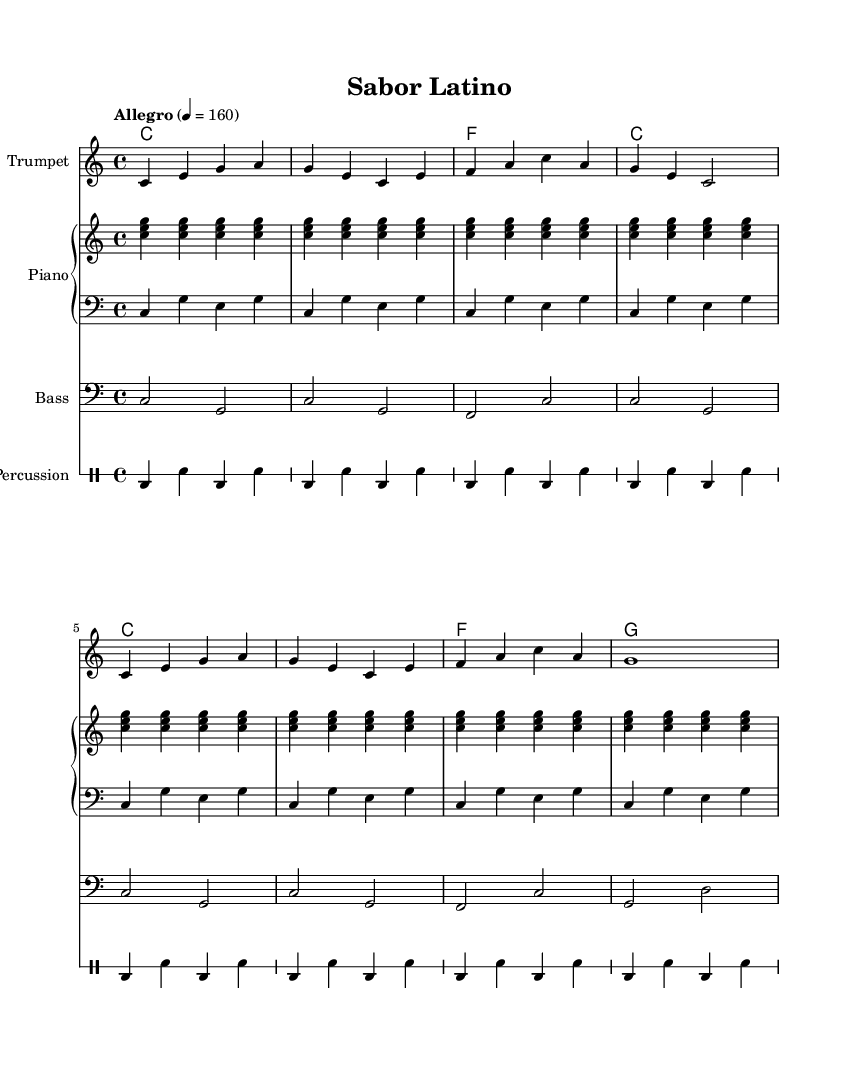What is the key signature of this music? The key signature is C major, which has no sharps or flats listed on the staff. Thus, the music is in the key of C major.
Answer: C major What is the time signature of the piece? The time signature shown in the music is 4/4, indicating four beats per measure and the quarter note gets one beat.
Answer: 4/4 What is the tempo marking for the music? The tempo marking states "Allegro" with a metronome marking of quarter note equals 160, suggesting a fast and lively pace.
Answer: Allegro, 160 How many measures are in the trumpet melody? The trumpet melody consists of 8 measures, as counted by the number of bar lines present in the staff.
Answer: 8 What type of musical event is this piece suitable for? The piece is a traditional salsa music, which typically features Latin rhythms and is suitable for dance events and cultural festivals focusing on Latin music and dance.
Answer: Dance event What instrument is the melody written for? The melody is specifically written for the trumpet, as indicated by the staff label stating "Trumpet."
Answer: Trumpet What chord is played in the first measure of the piano? The first measure of the piano chords shows a C major chord (C major triad), as indicated by the chord symbols used in the music.
Answer: C 